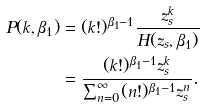Convert formula to latex. <formula><loc_0><loc_0><loc_500><loc_500>P ( k , \beta _ { 1 } ) & = ( k ! ) ^ { \beta _ { 1 } - 1 } \frac { z _ { s } ^ { k } } { H ( z _ { s } , \beta _ { 1 } ) } \\ & = \frac { ( k ! ) ^ { \beta _ { 1 } - 1 } z _ { s } ^ { k } } { \sum _ { n = 0 } ^ { \infty } ( n ! ) ^ { \beta _ { 1 } - 1 } z _ { s } ^ { n } } .</formula> 